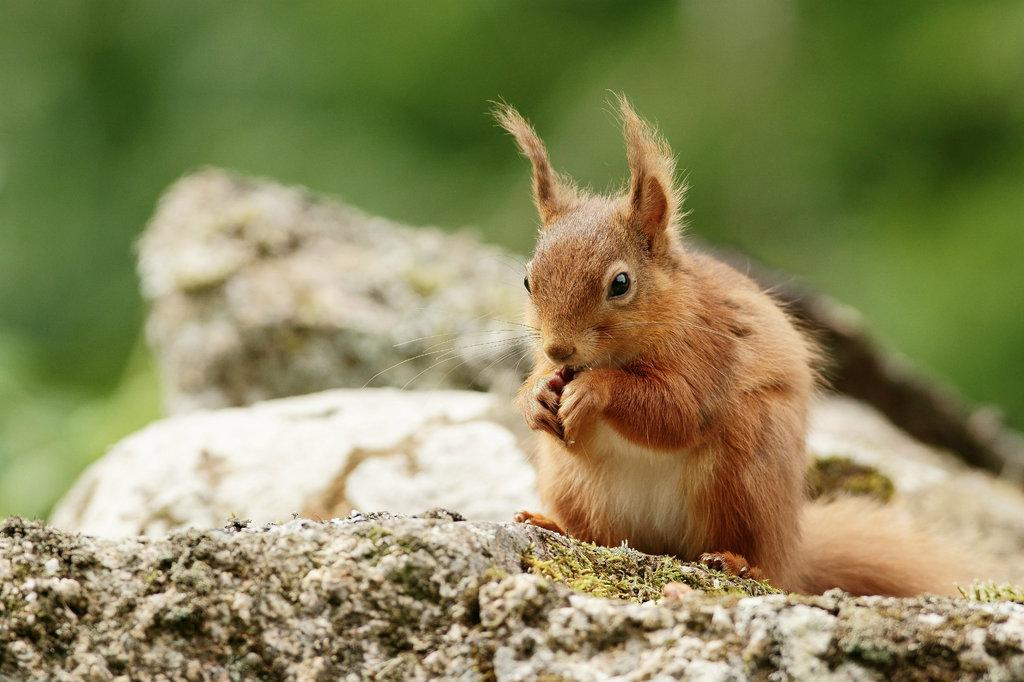What animal can be seen in the image? There is a squirrel in the image. What is the squirrel standing on? The squirrel is on a stone. How many stones are visible in the background? There are two stones in the background, one above the other. Can you describe the background of the image? The background appears blurry. What type of plant can be seen growing in the liquid in the image? There is no plant or liquid present in the image; it features a squirrel on a stone with a blurry background. 